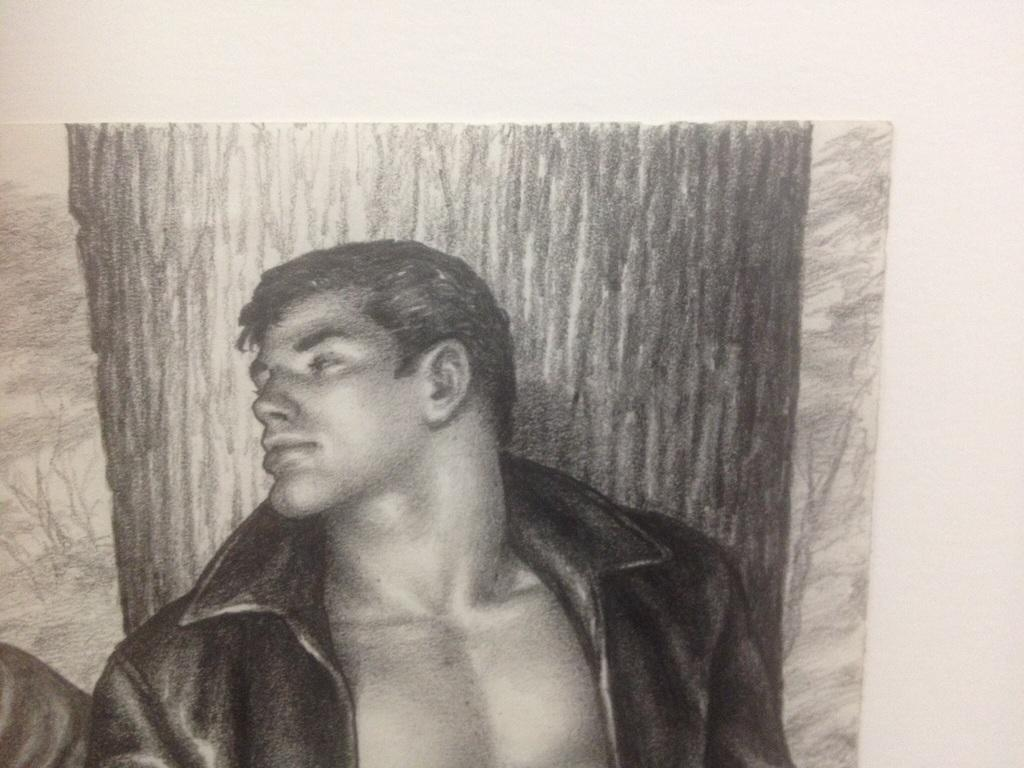What is the main subject of the image? The image contains an art piece. What does the art piece depict? The art piece depicts a man and a tree. How many balls are visible in the image? There are no balls present in the image. What type of snakes can be seen in the art piece? There are no snakes depicted in the art piece; it features a man and a tree. 